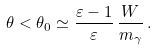<formula> <loc_0><loc_0><loc_500><loc_500>\theta < \theta _ { 0 } \simeq \frac { \varepsilon - 1 } { \varepsilon } \, \frac { W } { m _ { \gamma } } \, .</formula> 